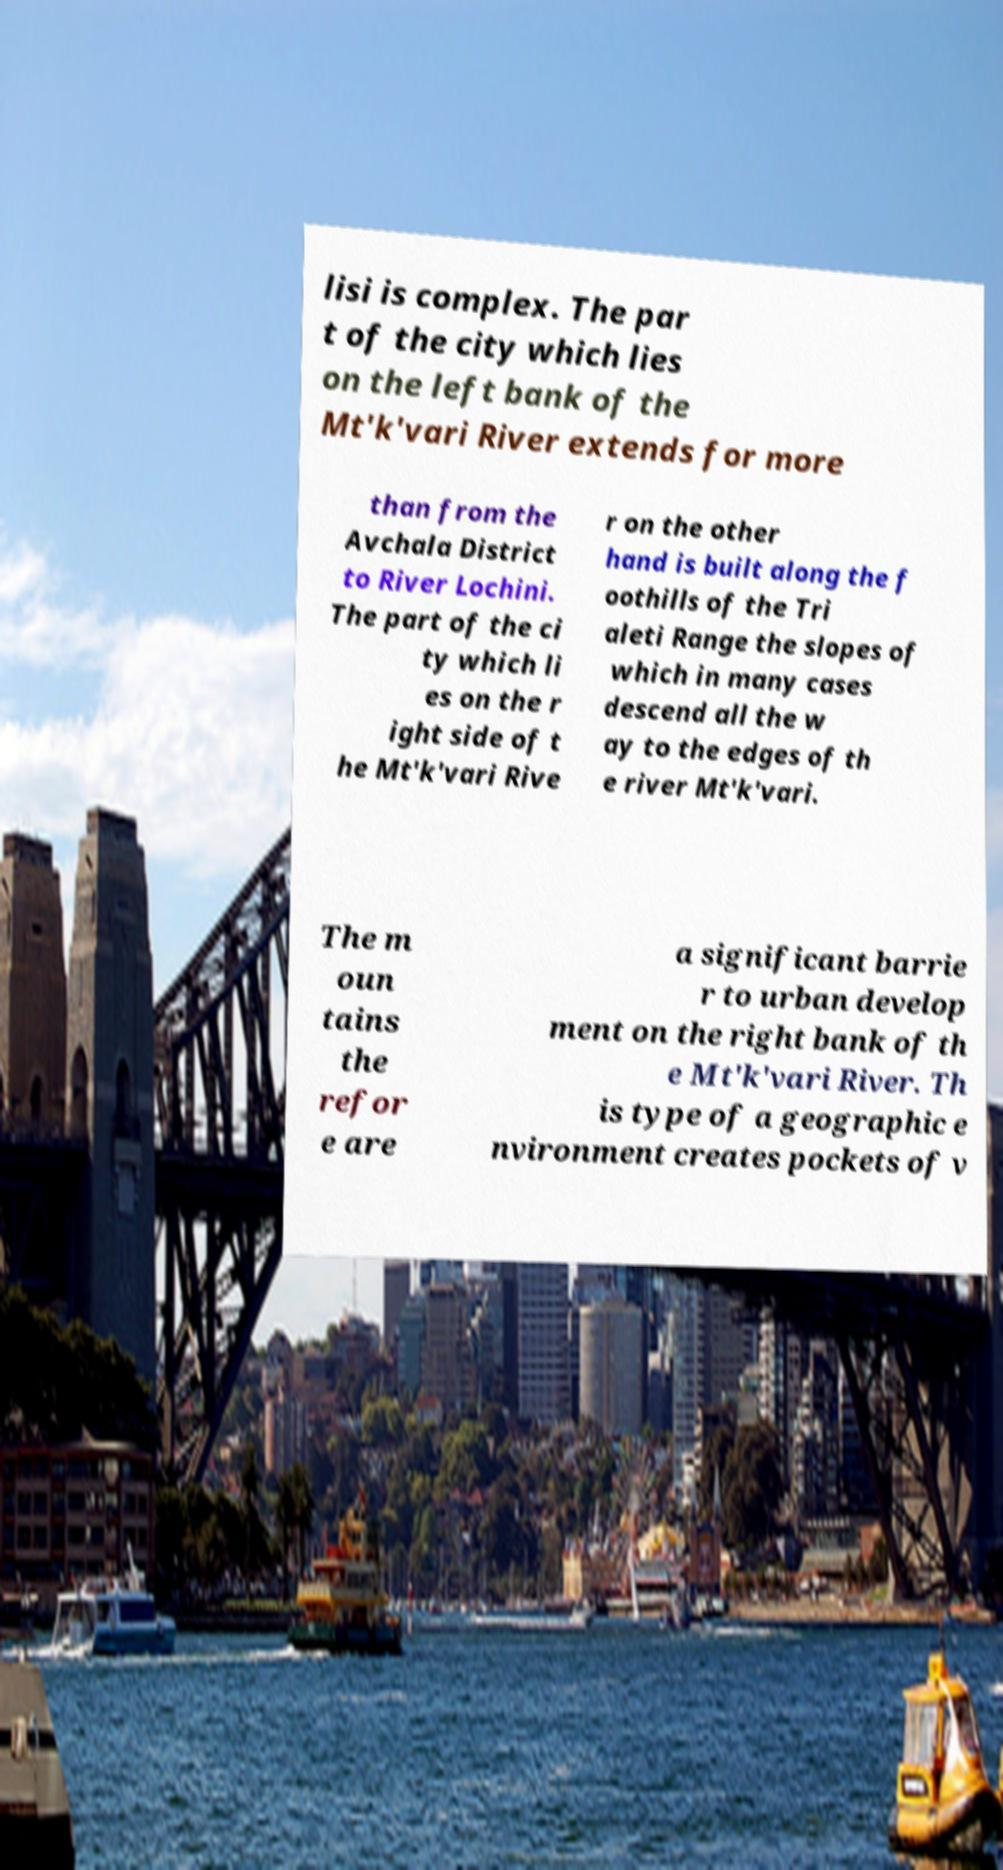There's text embedded in this image that I need extracted. Can you transcribe it verbatim? lisi is complex. The par t of the city which lies on the left bank of the Mt'k'vari River extends for more than from the Avchala District to River Lochini. The part of the ci ty which li es on the r ight side of t he Mt'k'vari Rive r on the other hand is built along the f oothills of the Tri aleti Range the slopes of which in many cases descend all the w ay to the edges of th e river Mt'k'vari. The m oun tains the refor e are a significant barrie r to urban develop ment on the right bank of th e Mt'k'vari River. Th is type of a geographic e nvironment creates pockets of v 